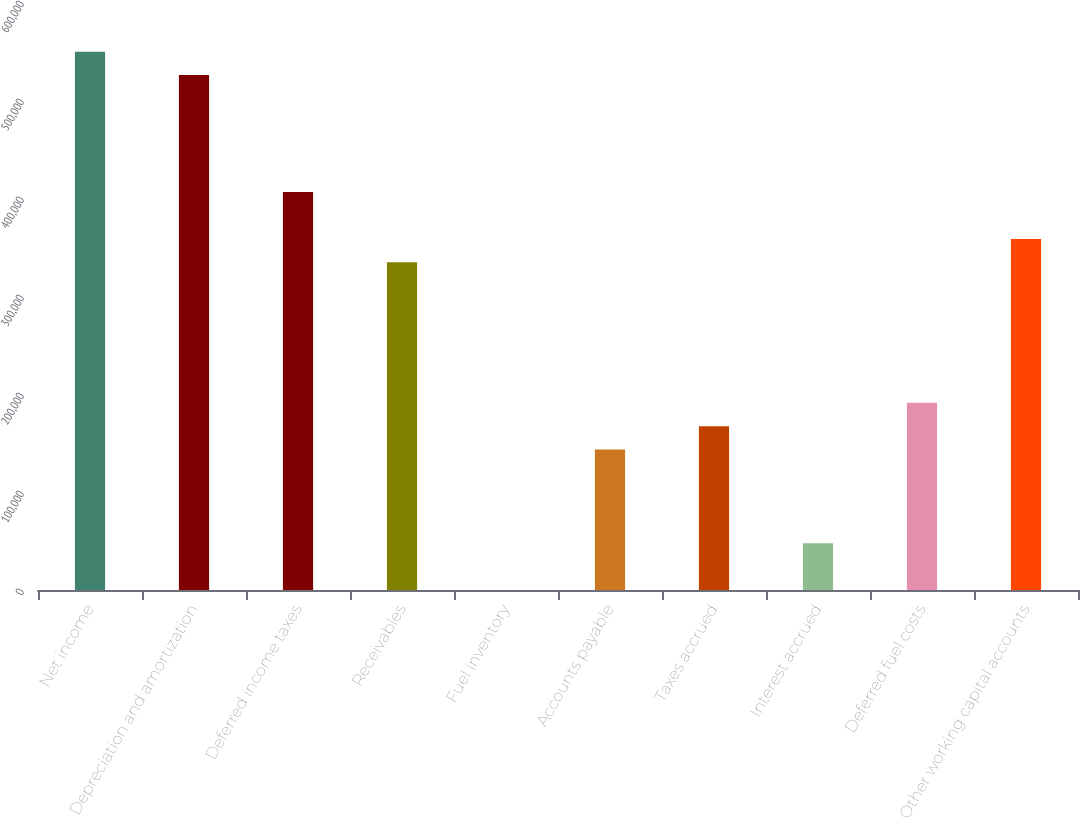<chart> <loc_0><loc_0><loc_500><loc_500><bar_chart><fcel>Net income<fcel>Depreciation and amortization<fcel>Deferred income taxes<fcel>Receivables<fcel>Fuel inventory<fcel>Accounts payable<fcel>Taxes accrued<fcel>Interest accrued<fcel>Deferred fuel costs<fcel>Other working capital accounts<nl><fcel>549310<fcel>525427<fcel>406014<fcel>334367<fcel>12<fcel>143307<fcel>167190<fcel>47777<fcel>191072<fcel>358250<nl></chart> 